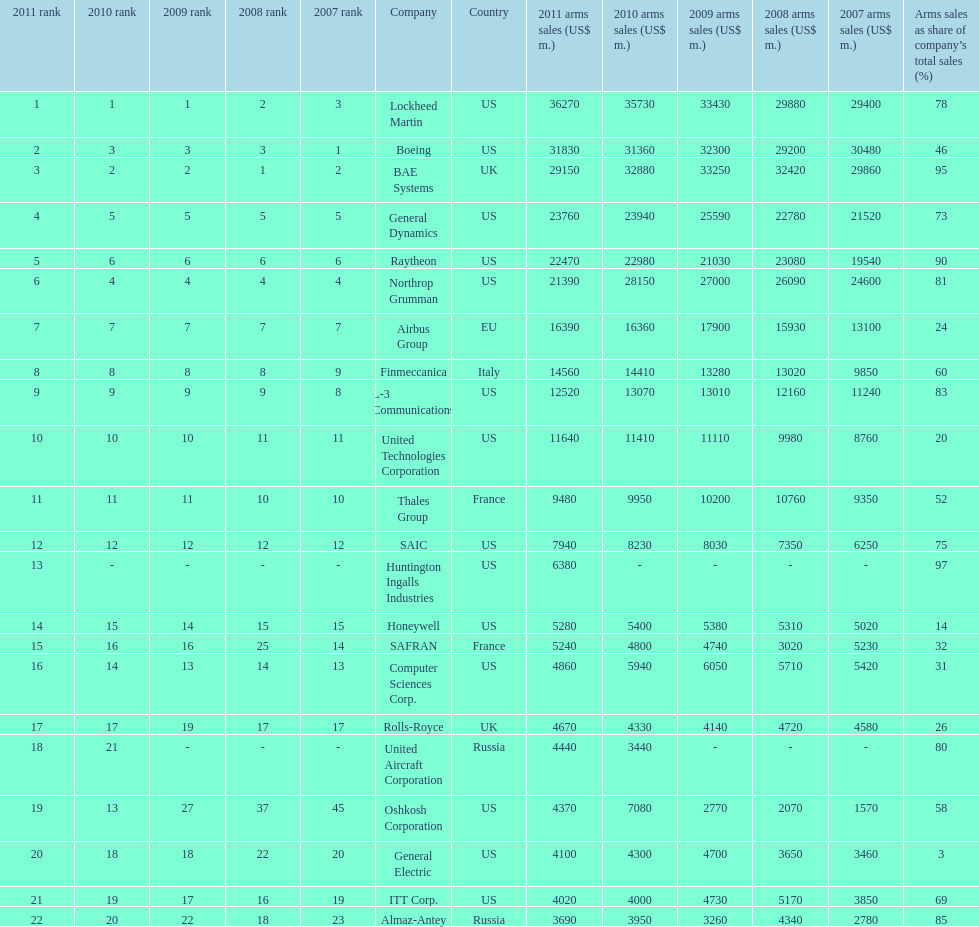What is the difference of the amount sold between boeing and general dynamics in 2007? 8960. 